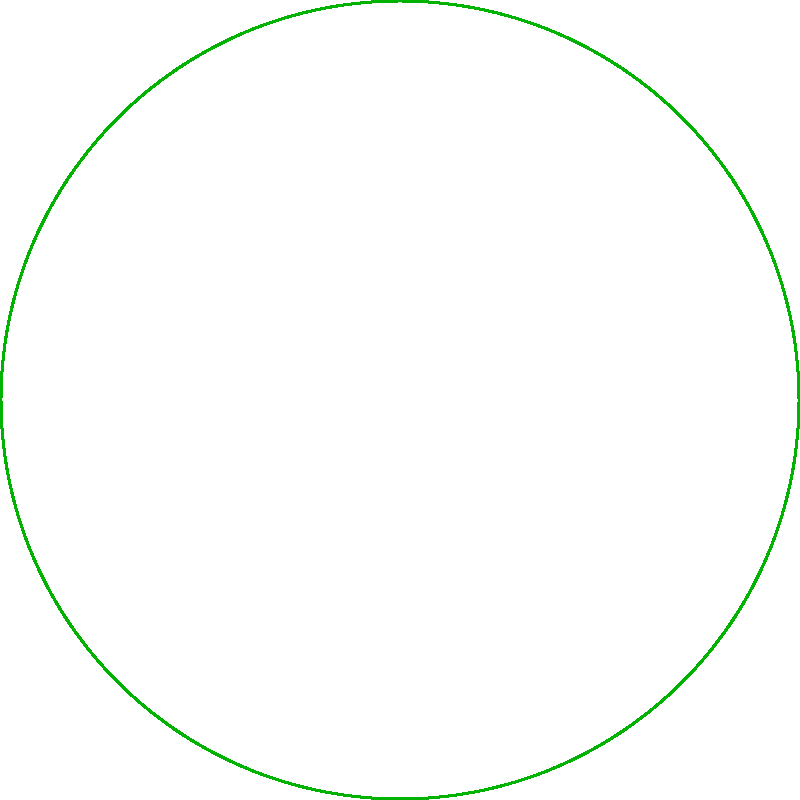A colorful butterfly is observed flying in a circular garden. Its flight path is mapped using polar coordinates $(r,\theta)$, where $r$ is the distance from the center in meters, and $\theta$ is the angle in degrees. The butterfly's path passes through points A$(2,30°)$, B$(3,120°)$, C$(4,210°)$, and D$(3,300°)$. What is the total distance traveled by the butterfly between points A and C, rounded to the nearest meter? To find the total distance traveled by the butterfly, we need to calculate the length of the curved path from A to B to C. We'll use the formula for arc length in polar coordinates:

$s = \int_{\theta_1}^{\theta_2} \sqrt{r^2 + (\frac{dr}{d\theta})^2} d\theta$

However, since we don't have a continuous function for $r(\theta)$, we'll approximate the distance by calculating the lengths of two circular arcs:

1. Arc from A to B:
   $r_1 = \frac{2+3}{2} = 2.5$ (average radius)
   $\Delta\theta_1 = 120° - 30° = 90°$
   $s_1 = 2.5 \cdot \frac{\pi}{180°} \cdot 90° \approx 3.93$ m

2. Arc from B to C:
   $r_2 = \frac{3+4}{2} = 3.5$ (average radius)
   $\Delta\theta_2 = 210° - 120° = 90°$
   $s_2 = 3.5 \cdot \frac{\pi}{180°} \cdot 90° \approx 5.50$ m

Total distance: $s_{total} = s_1 + s_2 \approx 3.93 + 5.50 = 9.43$ m

Rounding to the nearest meter: 9 m
Answer: 9 m 